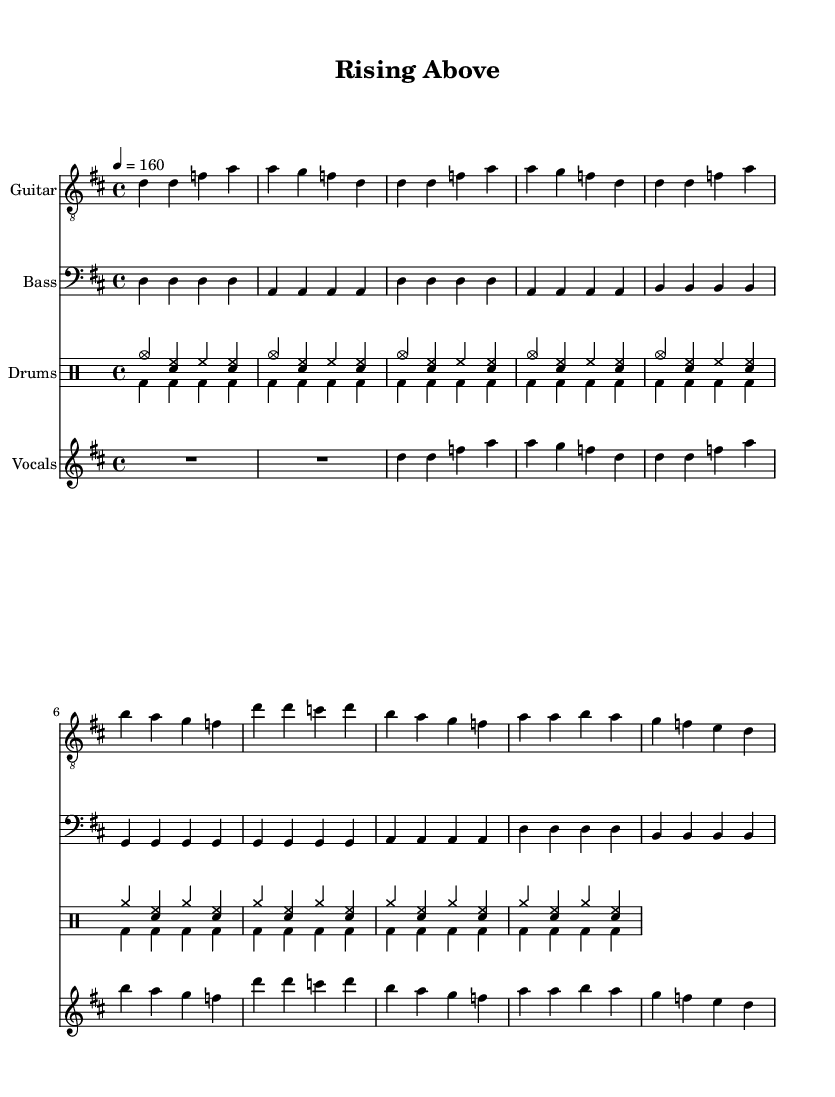What is the key signature of this music? The key signature in the music indicates the presence of two sharps, which corresponds to the D major scale. This can be observed in the global section at the beginning of the sheet music.
Answer: D major What is the time signature of the piece? The time signature is found in the global section of the music. Here, it is indicated as 4/4, meaning there are four beats in each measure.
Answer: 4/4 What is the tempo marking for this music? The tempo marking is specified in the global section of the music with "4 = 160," indicating that there are 160 beats per minute. This gives an understanding of the performance tempo.
Answer: 160 How many measures are there in the chorus? Counting the measures in the chorus, which is labeled clearly, we find a total of four measures. Each measure consists of the notes and rhythmic patterns detailed in the part for vocals.
Answer: 4 What kind of thematic content does the song represent? By analyzing the lyrics provided in the vocals section of the music, the themes of personal growth and overcoming adversity are evident, as the lyrics reflect a journey from struggle to empowerment.
Answer: Personal growth What happens to the dynamics in the transition from verse to chorus? In observing the structure, we note that the musical elements become more intense during the chorus, often characteristic of punk music, which emphasizes emotional peaks. This can involve louder vocals and more powerful instrumentation.
Answer: Increased intensity What role does the drums play in the overall structure of the song? The drums serve a foundational role throughout the piece, maintaining a driving rhythm that supports the energetic feel characteristic of punk music. The patterns indicated contribute to building momentum, especially in transitions between the verse and chorus.
Answer: Driving rhythm 